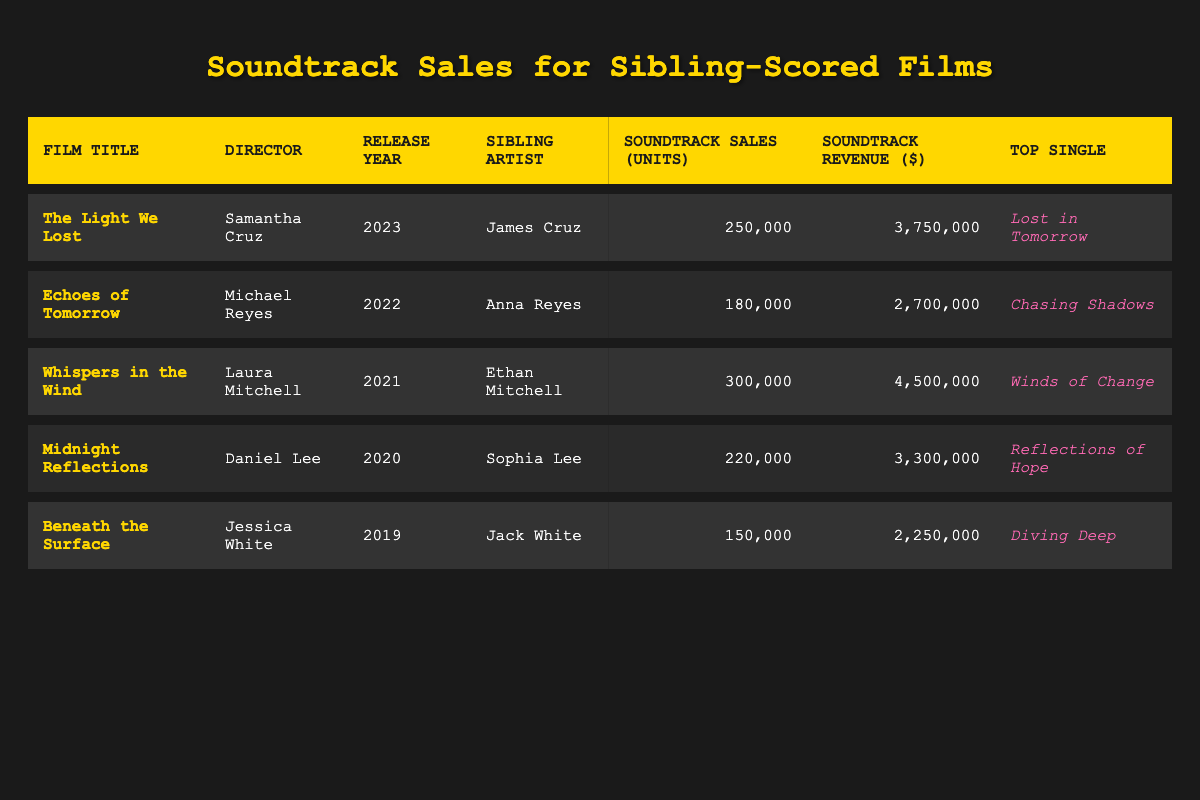What is the total number of soundtrack sales units for all films listed? To find the total number of soundtrack sales units, we need to add the units from each film. The sales units are: 250,000 + 180,000 + 300,000 + 220,000 + 150,000 = 1,100,000.
Answer: 1,100,000 Which film has the highest soundtrack sales revenue? By comparing the soundtrack sales revenue for each film, it can be identified that "Whispers in the Wind" has the highest revenue at $4,500,000.
Answer: Whispers in the Wind Did "Beneath the Surface" have more sales units than "Echoes of Tomorrow"? "Beneath the Surface" had 150,000 sales units, while "Echoes of Tomorrow" had 180,000 sales units, meaning "Beneath the Surface" had fewer sales units.
Answer: No What is the average soundtrack sales revenue for the films released in the last five years? To calculate the average soundtrack sales revenue, we add all the revenue figures: 3,750,000 + 2,700,000 + 4,500,000 + 3,300,000 + 2,250,000 = 16,500,000. Then divide by 5 (the number of films): 16,500,000 / 5 = 3,300,000.
Answer: 3,300,000 Which sibling artist has the most successful single based on the highest sales units of the film? The highest sales units are from "Whispers in the Wind" with 300,000 units sold. Therefore, Ethan Mitchell, sibling artist for that film, has the most successful single.
Answer: Ethan Mitchell In what year was the film "Midnight Reflections" released? The release year of "Midnight Reflections" is listed in the table as 2020.
Answer: 2020 How many films had a soundtrack sales revenue of over 3 million dollars? From the data, there are three films with revenues over 3 million: "The Light We Lost" ($3,750,000), "Whispers in the Wind" ($4,500,000), and "Midnight Reflections" ($3,300,000).
Answer: 3 What is the top single for "The Light We Lost"? The top single listed for "The Light We Lost" is "Lost in Tomorrow."
Answer: Lost in Tomorrow 